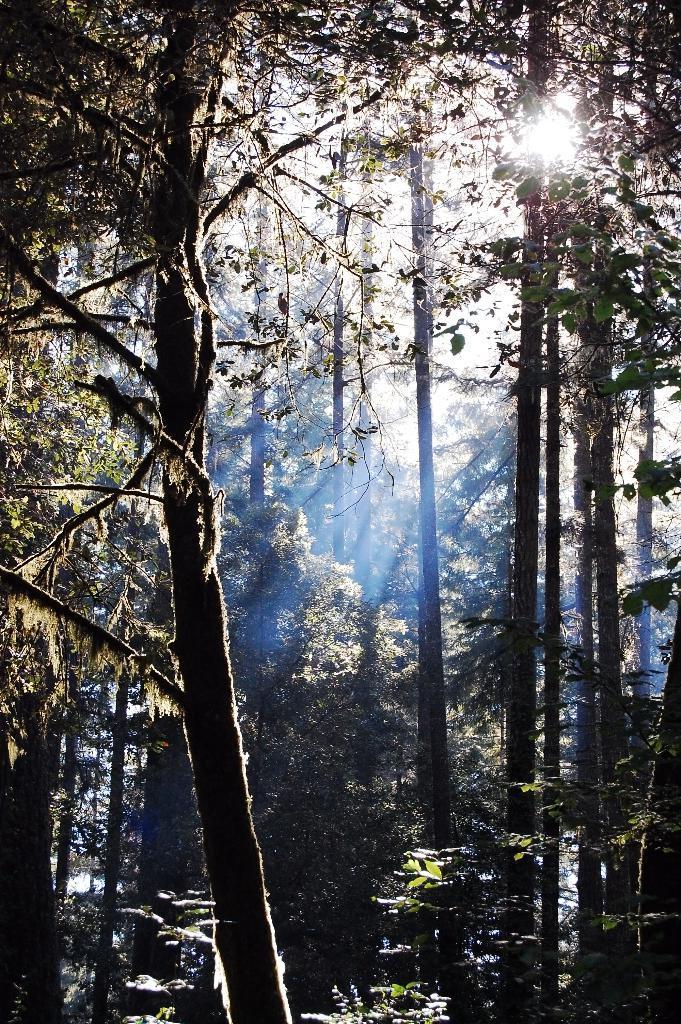Could you give a brief overview of what you see in this image? In this image I can see a trees. The sky is in white and blue color. 